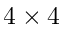Convert formula to latex. <formula><loc_0><loc_0><loc_500><loc_500>4 \times 4</formula> 